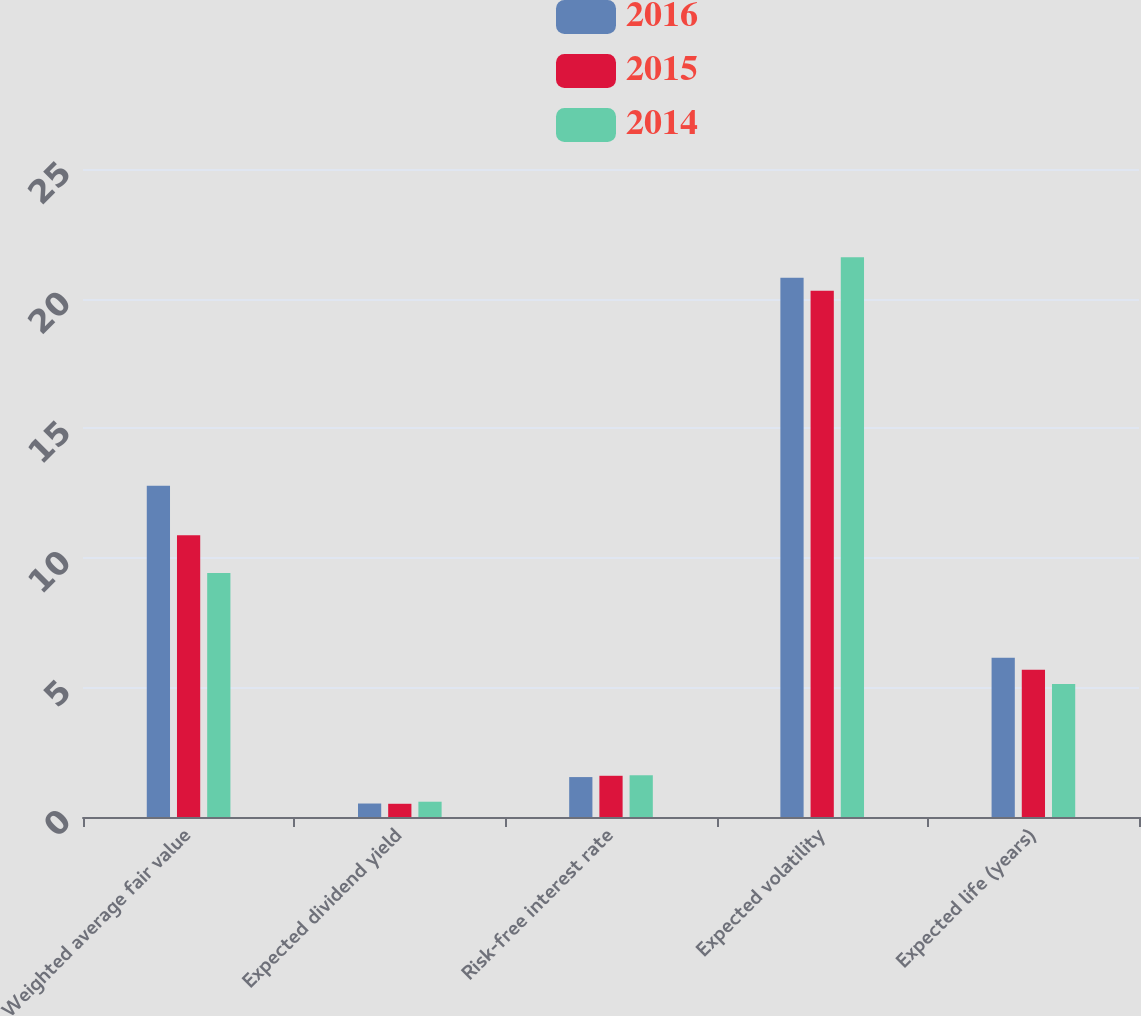<chart> <loc_0><loc_0><loc_500><loc_500><stacked_bar_chart><ecel><fcel>Weighted average fair value<fcel>Expected dividend yield<fcel>Risk-free interest rate<fcel>Expected volatility<fcel>Expected life (years)<nl><fcel>2016<fcel>12.78<fcel>0.52<fcel>1.54<fcel>20.8<fcel>6.14<nl><fcel>2015<fcel>10.87<fcel>0.51<fcel>1.59<fcel>20.3<fcel>5.68<nl><fcel>2014<fcel>9.41<fcel>0.59<fcel>1.61<fcel>21.6<fcel>5.13<nl></chart> 